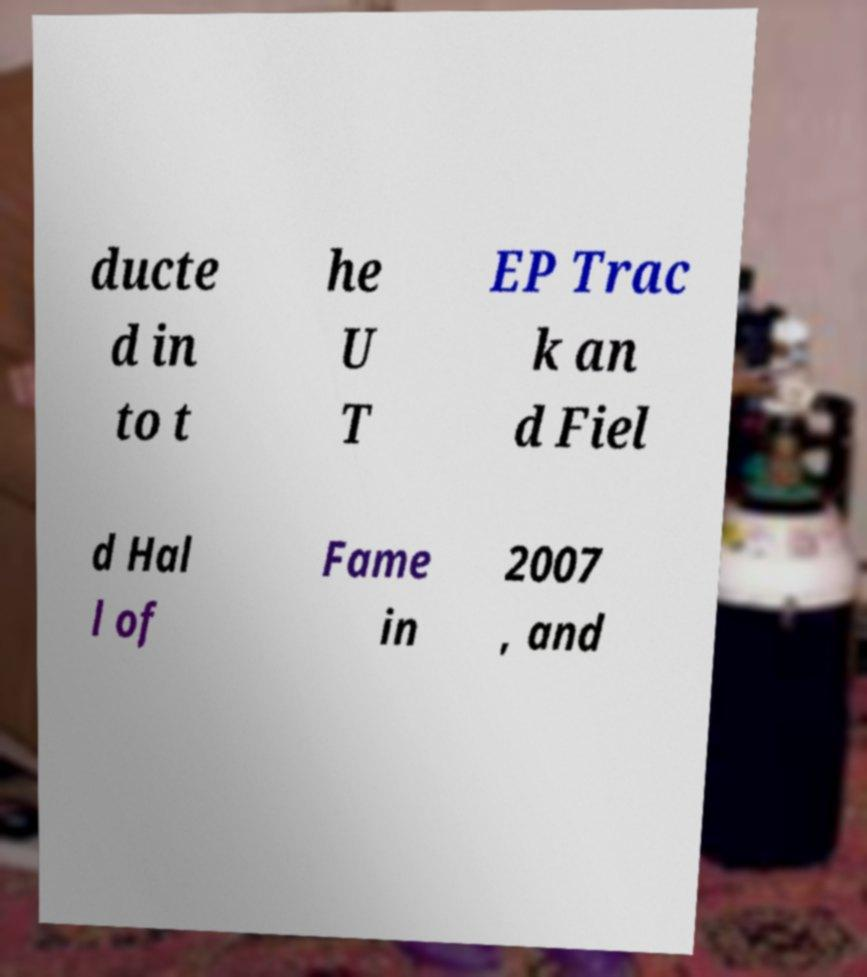Please read and relay the text visible in this image. What does it say? ducte d in to t he U T EP Trac k an d Fiel d Hal l of Fame in 2007 , and 